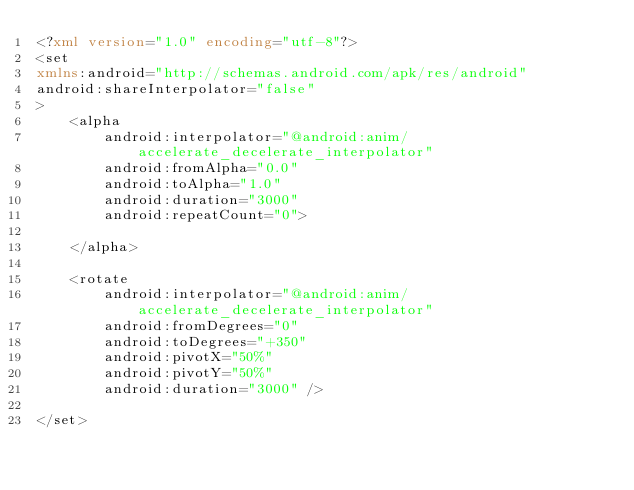<code> <loc_0><loc_0><loc_500><loc_500><_XML_><?xml version="1.0" encoding="utf-8"?>
<set
xmlns:android="http://schemas.android.com/apk/res/android"
android:shareInterpolator="false"
>
    <alpha
        android:interpolator="@android:anim/accelerate_decelerate_interpolator"
        android:fromAlpha="0.0"
        android:toAlpha="1.0"
        android:duration="3000"
        android:repeatCount="0">
        
    </alpha>
    
    <rotate 
        android:interpolator="@android:anim/accelerate_decelerate_interpolator"     
        android:fromDegrees="0" 
        android:toDegrees="+350"         
        android:pivotX="50%" 
        android:pivotY="50%"         
        android:duration="3000" />
        
</set>
</code> 